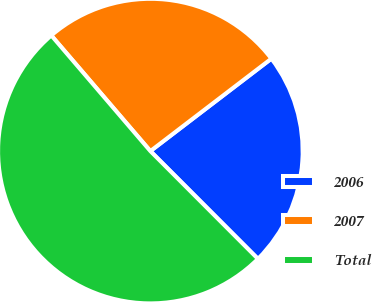<chart> <loc_0><loc_0><loc_500><loc_500><pie_chart><fcel>2006<fcel>2007<fcel>Total<nl><fcel>22.9%<fcel>25.89%<fcel>51.21%<nl></chart> 